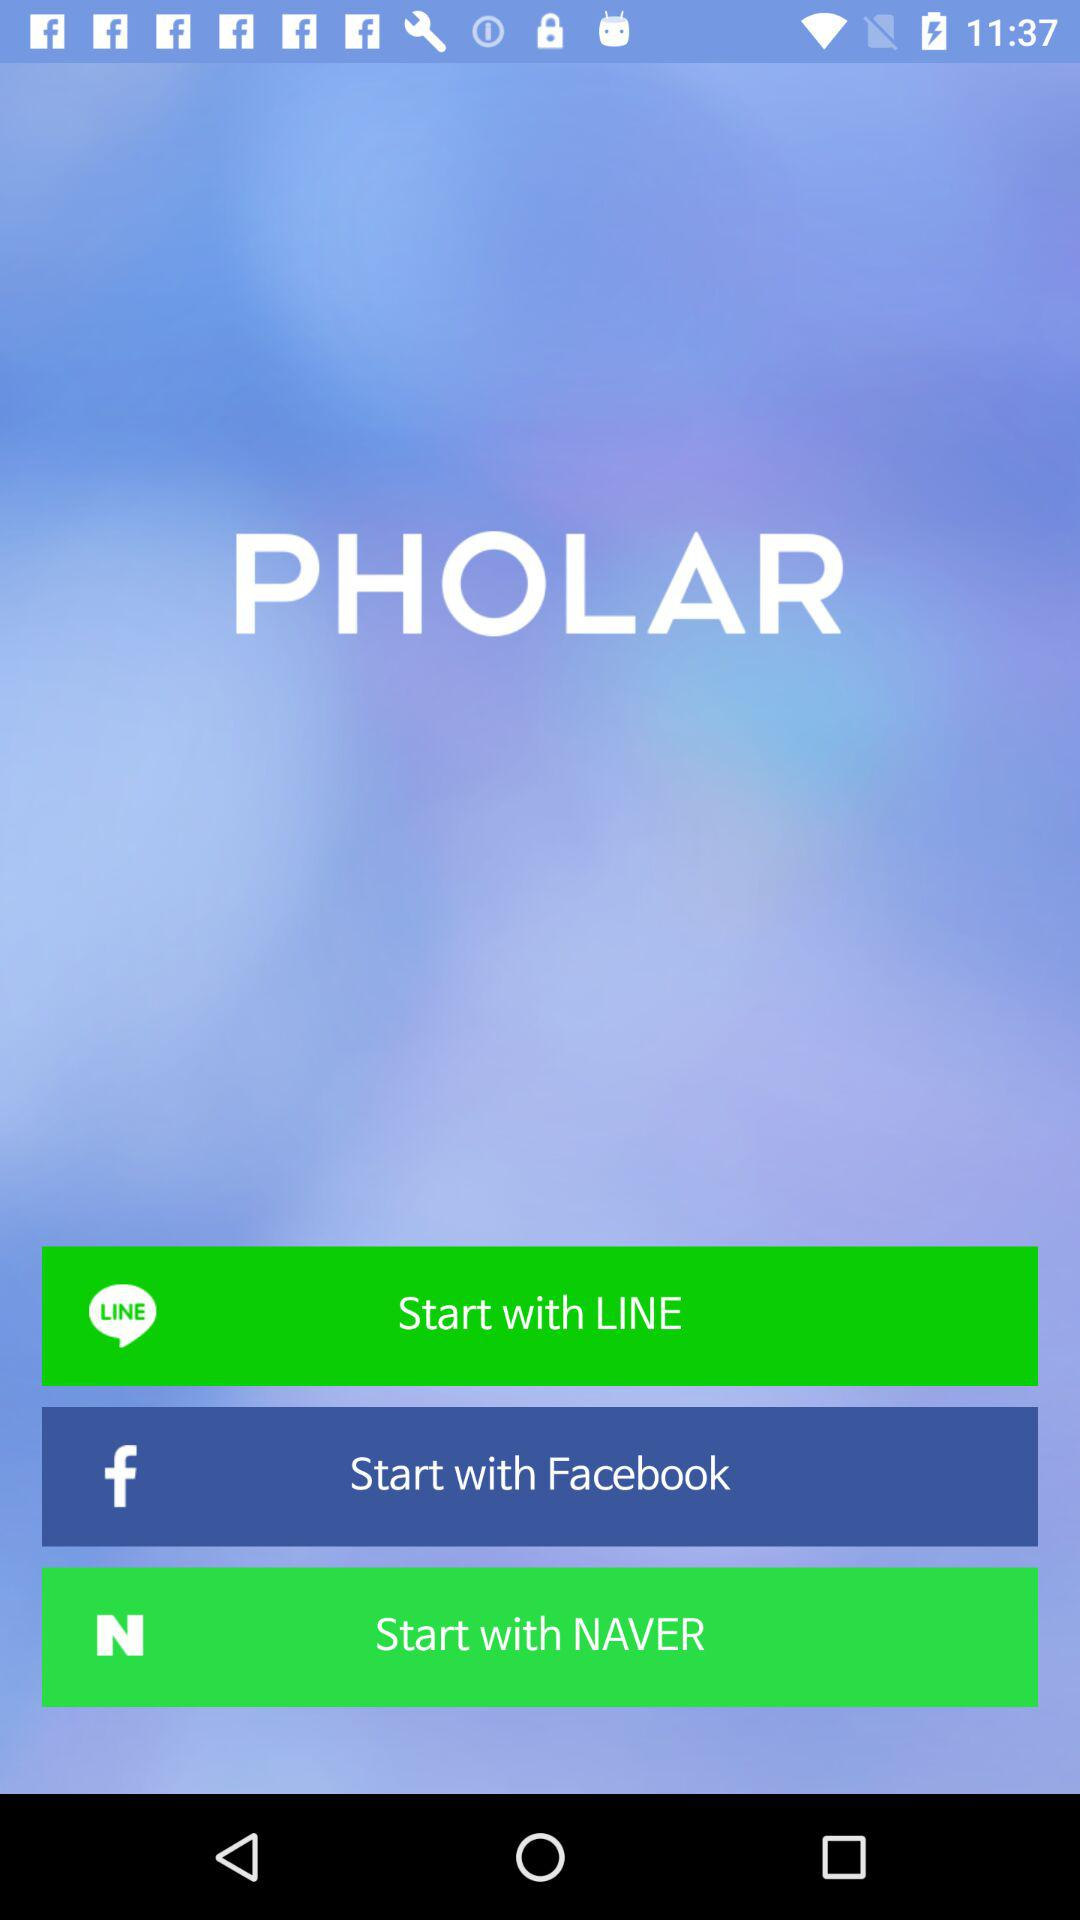What is the name of the application? The name of the application is "PHOLAR". 